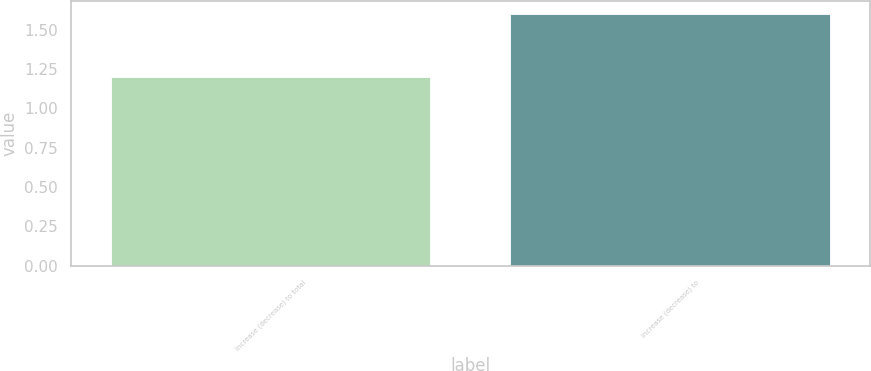<chart> <loc_0><loc_0><loc_500><loc_500><bar_chart><fcel>Increase (decrease) to total<fcel>Increase (decrease) to<nl><fcel>1.2<fcel>1.6<nl></chart> 